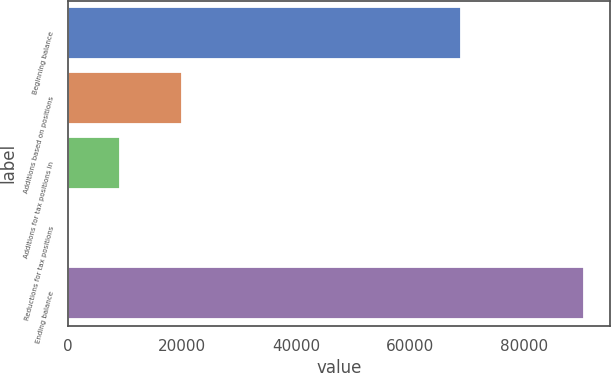Convert chart. <chart><loc_0><loc_0><loc_500><loc_500><bar_chart><fcel>Beginning balance<fcel>Additions based on positions<fcel>Additions for tax positions in<fcel>Reductions for tax positions<fcel>Ending balance<nl><fcel>69052<fcel>20036<fcel>9087.6<fcel>29<fcel>90615<nl></chart> 